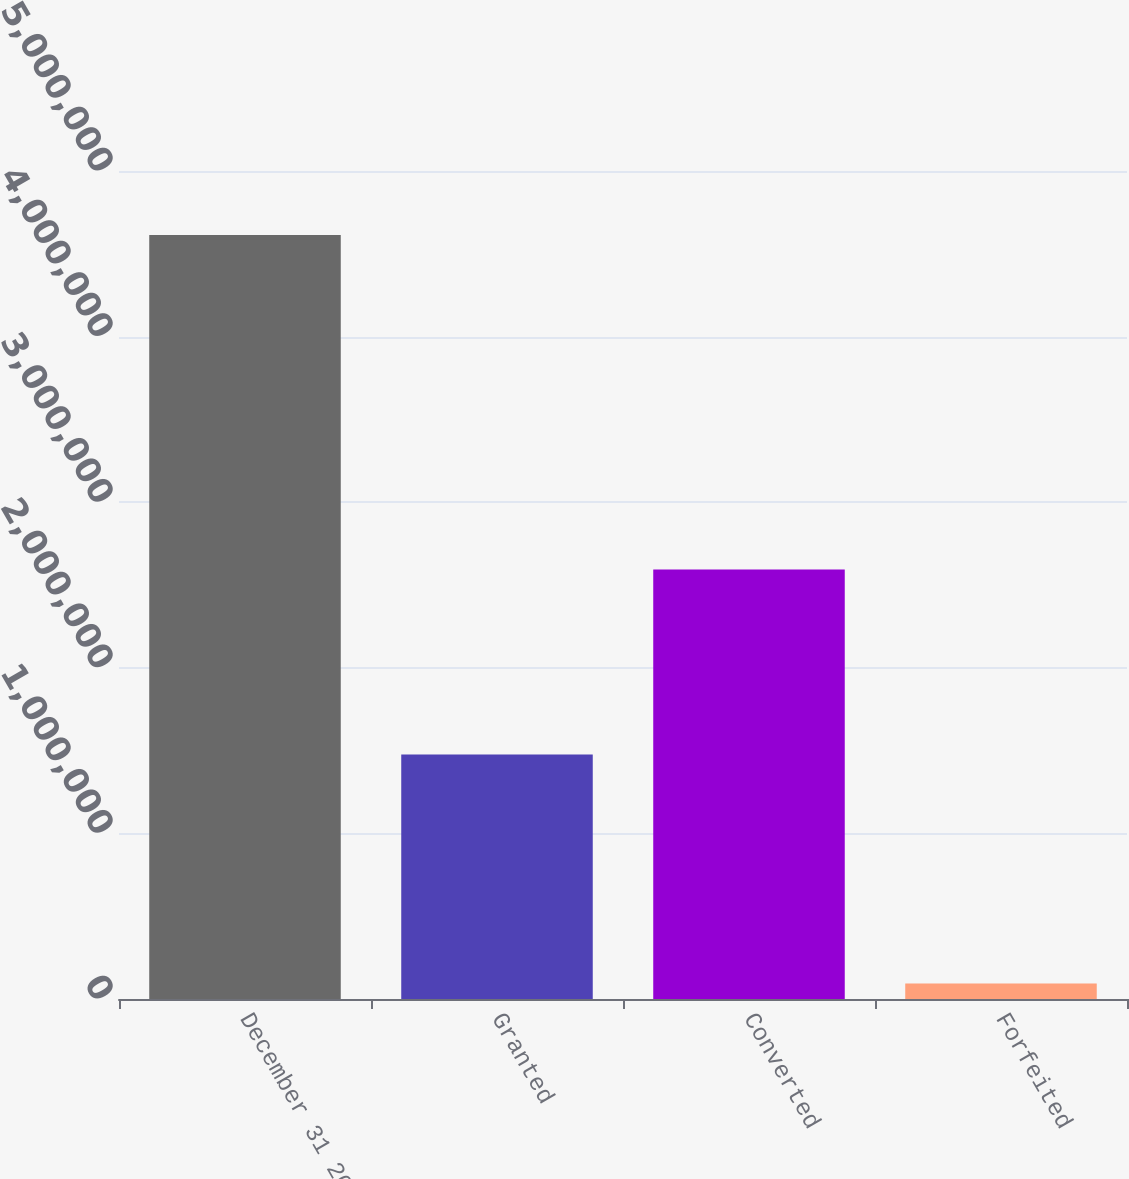Convert chart. <chart><loc_0><loc_0><loc_500><loc_500><bar_chart><fcel>December 31 2013<fcel>Granted<fcel>Converted<fcel>Forfeited<nl><fcel>4.61281e+06<fcel>1.47628e+06<fcel>2.59325e+06<fcel>93929<nl></chart> 